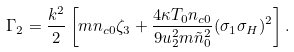<formula> <loc_0><loc_0><loc_500><loc_500>\Gamma _ { 2 } = \frac { k ^ { 2 } } { 2 } \left [ m n _ { c 0 } \zeta _ { 3 } + \frac { 4 \kappa T _ { 0 } n _ { c 0 } } { 9 u _ { 2 } ^ { 2 } m \tilde { n } _ { 0 } ^ { 2 } } ( \sigma _ { 1 } \sigma _ { H } ) ^ { 2 } \right ] .</formula> 